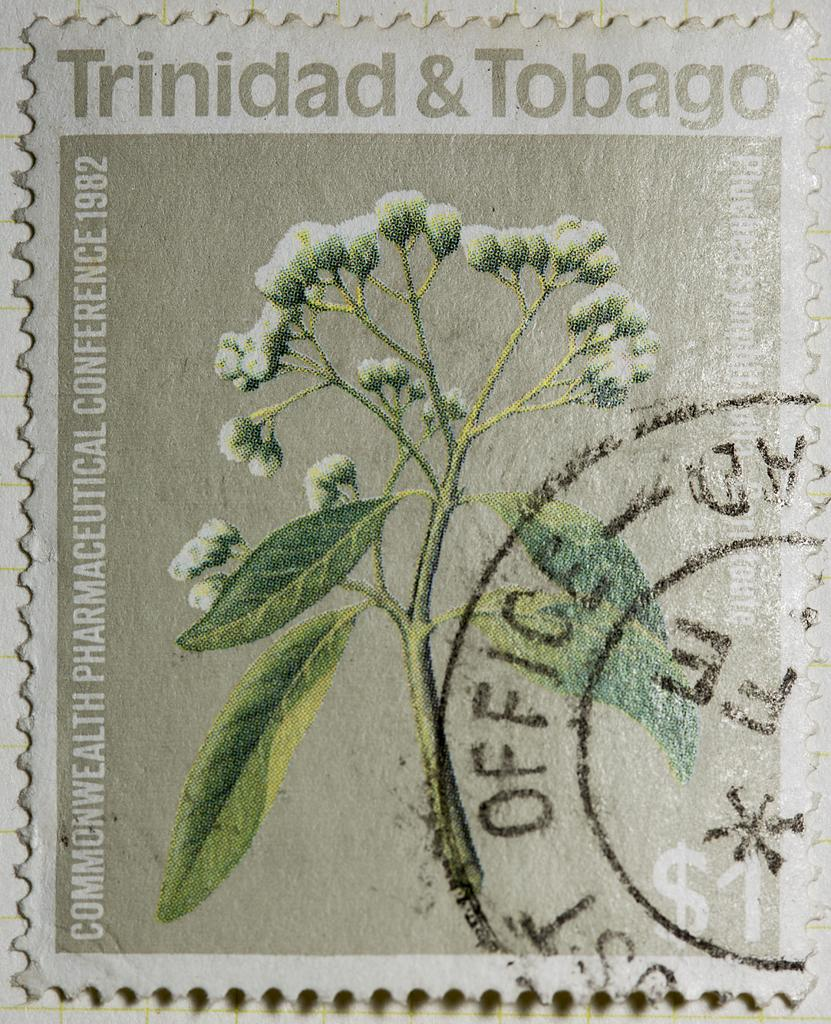What is the main subject in the center of the image? There is a stem with leaves and flowers in the center of the image. What else can be seen on the right side of the image? There is text on the right side of the image. Is there any text in other areas of the image? Yes, there is text at the top of the image. What type of cart is being pulled by the band in the image? There is no cart or band present in the image; it only features a stem with leaves and flowers, along with text on the right side and at the top. 